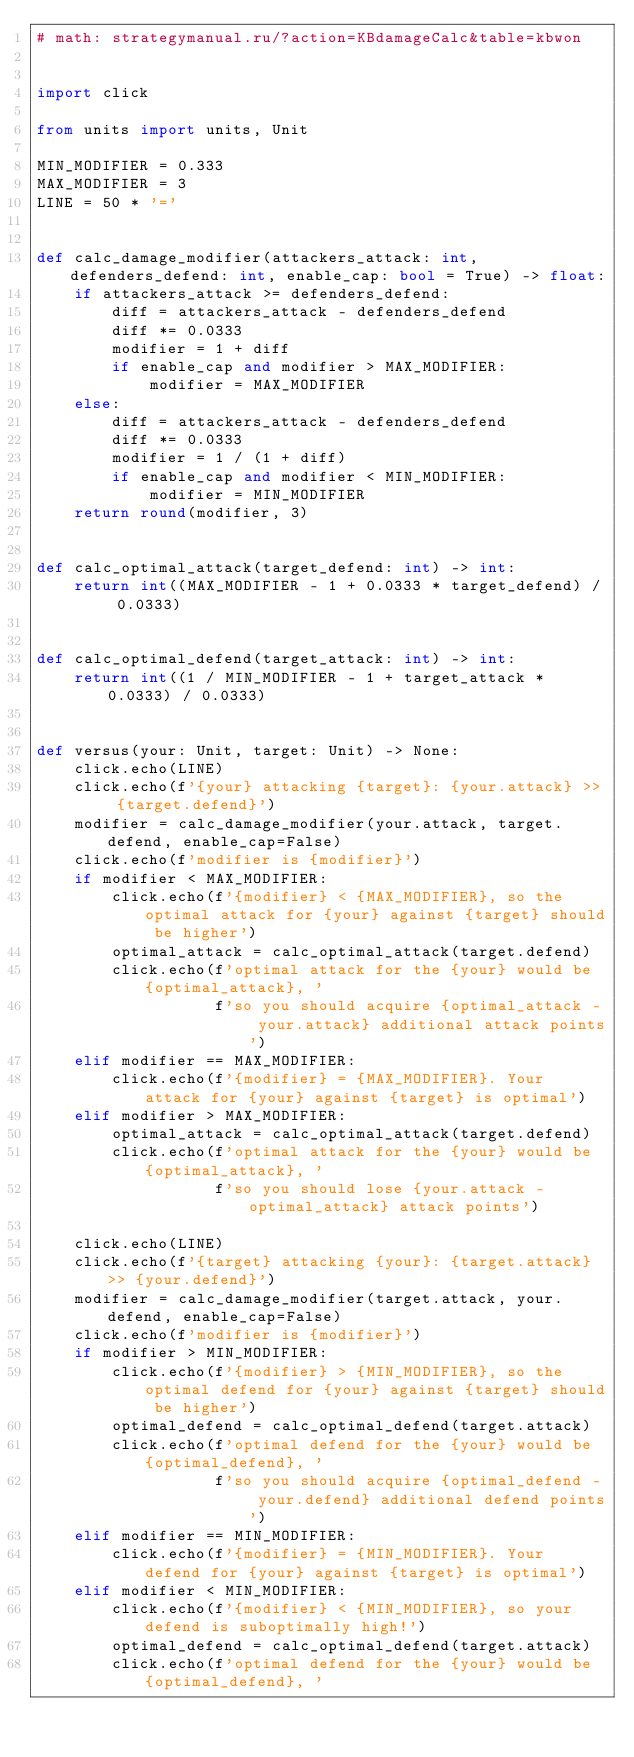<code> <loc_0><loc_0><loc_500><loc_500><_Python_># math: strategymanual.ru/?action=KBdamageCalc&table=kbwon


import click

from units import units, Unit

MIN_MODIFIER = 0.333
MAX_MODIFIER = 3
LINE = 50 * '='


def calc_damage_modifier(attackers_attack: int, defenders_defend: int, enable_cap: bool = True) -> float:
    if attackers_attack >= defenders_defend:
        diff = attackers_attack - defenders_defend
        diff *= 0.0333
        modifier = 1 + diff
        if enable_cap and modifier > MAX_MODIFIER:
            modifier = MAX_MODIFIER
    else:
        diff = attackers_attack - defenders_defend
        diff *= 0.0333
        modifier = 1 / (1 + diff)
        if enable_cap and modifier < MIN_MODIFIER:
            modifier = MIN_MODIFIER
    return round(modifier, 3)


def calc_optimal_attack(target_defend: int) -> int:
    return int((MAX_MODIFIER - 1 + 0.0333 * target_defend) / 0.0333)


def calc_optimal_defend(target_attack: int) -> int:
    return int((1 / MIN_MODIFIER - 1 + target_attack * 0.0333) / 0.0333)


def versus(your: Unit, target: Unit) -> None:
    click.echo(LINE)
    click.echo(f'{your} attacking {target}: {your.attack} >> {target.defend}')
    modifier = calc_damage_modifier(your.attack, target.defend, enable_cap=False)
    click.echo(f'modifier is {modifier}')
    if modifier < MAX_MODIFIER:
        click.echo(f'{modifier} < {MAX_MODIFIER}, so the optimal attack for {your} against {target} should be higher')
        optimal_attack = calc_optimal_attack(target.defend)
        click.echo(f'optimal attack for the {your} would be {optimal_attack}, '
                   f'so you should acquire {optimal_attack - your.attack} additional attack points')
    elif modifier == MAX_MODIFIER:
        click.echo(f'{modifier} = {MAX_MODIFIER}. Your attack for {your} against {target} is optimal')
    elif modifier > MAX_MODIFIER:
        optimal_attack = calc_optimal_attack(target.defend)
        click.echo(f'optimal attack for the {your} would be {optimal_attack}, '
                   f'so you should lose {your.attack - optimal_attack} attack points')

    click.echo(LINE)
    click.echo(f'{target} attacking {your}: {target.attack} >> {your.defend}')
    modifier = calc_damage_modifier(target.attack, your.defend, enable_cap=False)
    click.echo(f'modifier is {modifier}')
    if modifier > MIN_MODIFIER:
        click.echo(f'{modifier} > {MIN_MODIFIER}, so the optimal defend for {your} against {target} should be higher')
        optimal_defend = calc_optimal_defend(target.attack)
        click.echo(f'optimal defend for the {your} would be {optimal_defend}, '
                   f'so you should acquire {optimal_defend - your.defend} additional defend points')
    elif modifier == MIN_MODIFIER:
        click.echo(f'{modifier} = {MIN_MODIFIER}. Your defend for {your} against {target} is optimal')
    elif modifier < MIN_MODIFIER:
        click.echo(f'{modifier} < {MIN_MODIFIER}, so your defend is suboptimally high!')
        optimal_defend = calc_optimal_defend(target.attack)
        click.echo(f'optimal defend for the {your} would be {optimal_defend}, '</code> 